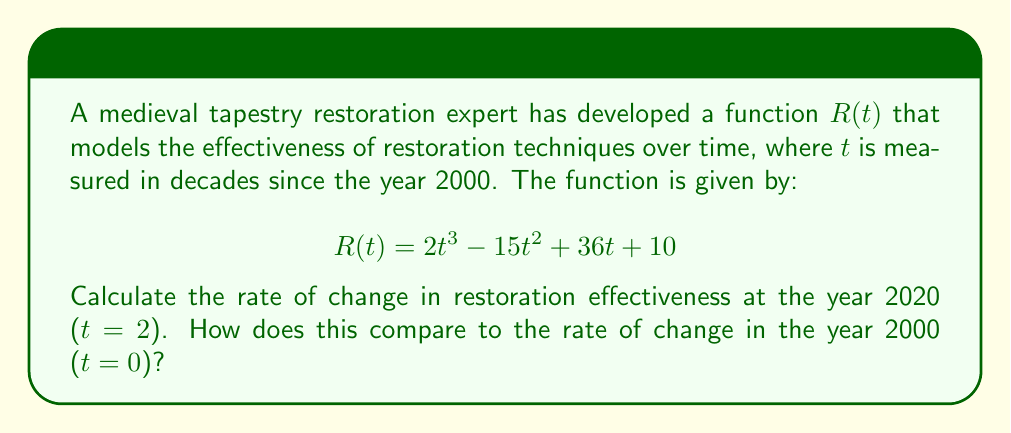Teach me how to tackle this problem. To solve this problem, we need to follow these steps:

1. Find the derivative of the function $R(t)$:
   $$R'(t) = \frac{d}{dt}(2t^3 - 15t^2 + 36t + 10)$$
   $$R'(t) = 6t^2 - 30t + 36$$

2. Calculate the rate of change in 2020 (t = 2):
   $$R'(2) = 6(2)^2 - 30(2) + 36$$
   $$R'(2) = 24 - 60 + 36 = 0$$

3. Calculate the rate of change in 2000 (t = 0):
   $$R'(0) = 6(0)^2 - 30(0) + 36$$
   $$R'(0) = 36$$

4. Compare the two rates:
   The rate of change in 2020 is 0, indicating that the effectiveness of restoration techniques is neither increasing nor decreasing at that point.
   The rate of change in 2000 is 36, indicating a rapid increase in the effectiveness of restoration techniques at the beginning of the millennium.
Answer: $R'(2) = 0$, $R'(0) = 36$; The rate of change decreased from 36 in 2000 to 0 in 2020. 